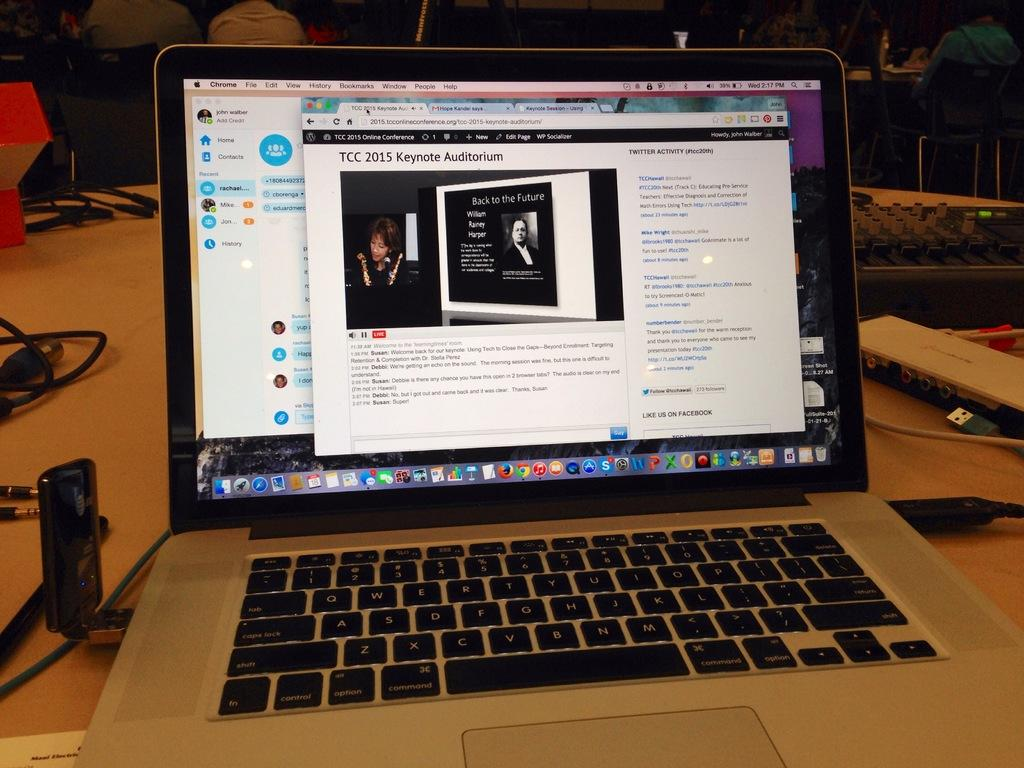<image>
Describe the image concisely. Laptop screen and keyboard that has the words: TCC 2015 Keynote Auditorium on the top. 